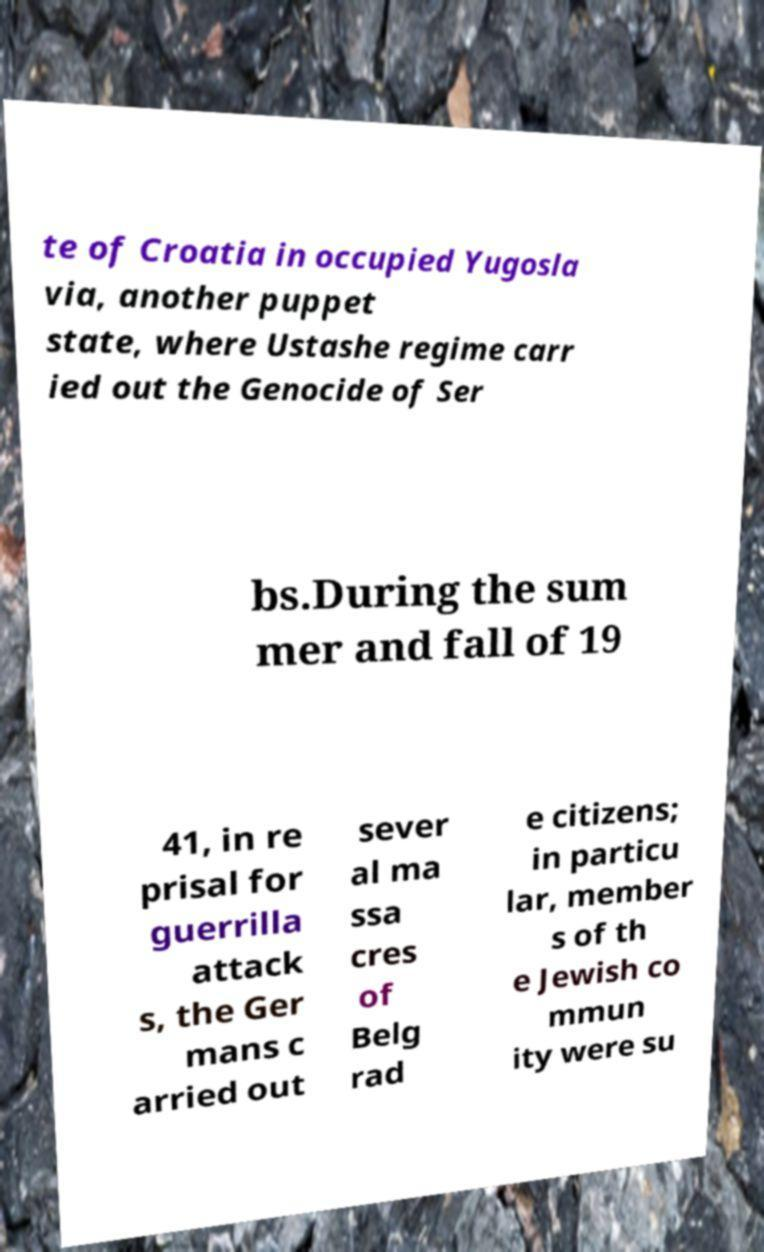What messages or text are displayed in this image? I need them in a readable, typed format. te of Croatia in occupied Yugosla via, another puppet state, where Ustashe regime carr ied out the Genocide of Ser bs.During the sum mer and fall of 19 41, in re prisal for guerrilla attack s, the Ger mans c arried out sever al ma ssa cres of Belg rad e citizens; in particu lar, member s of th e Jewish co mmun ity were su 